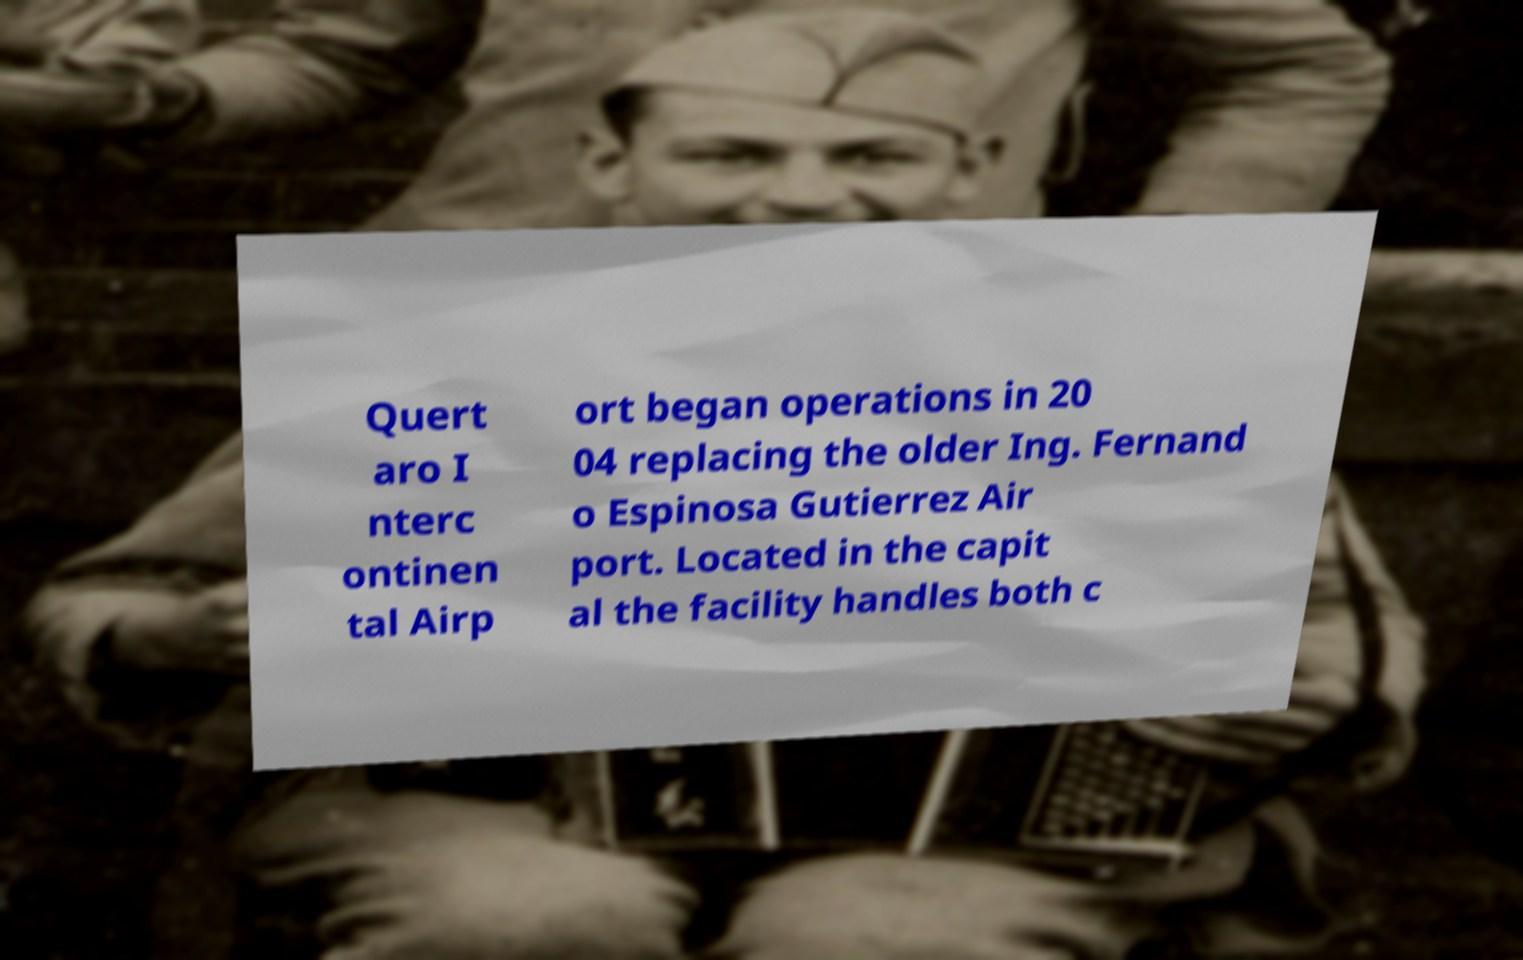I need the written content from this picture converted into text. Can you do that? Quert aro I nterc ontinen tal Airp ort began operations in 20 04 replacing the older Ing. Fernand o Espinosa Gutierrez Air port. Located in the capit al the facility handles both c 